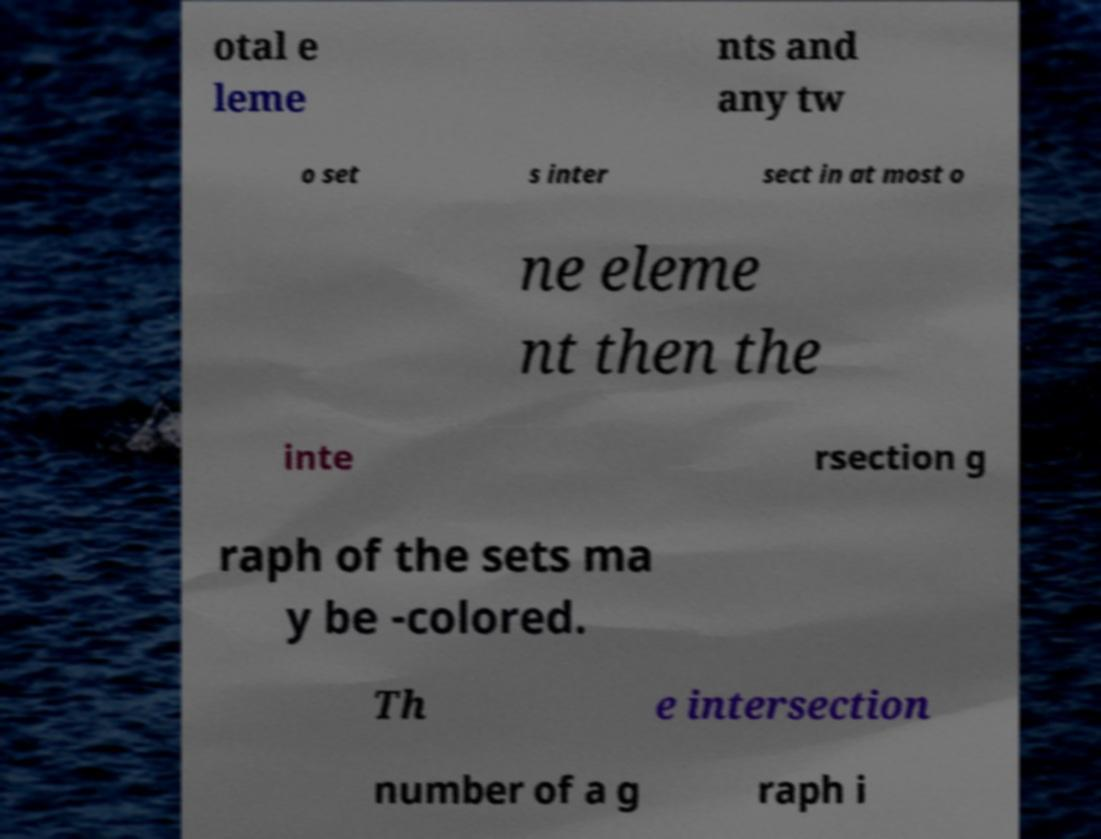What messages or text are displayed in this image? I need them in a readable, typed format. otal e leme nts and any tw o set s inter sect in at most o ne eleme nt then the inte rsection g raph of the sets ma y be -colored. Th e intersection number of a g raph i 